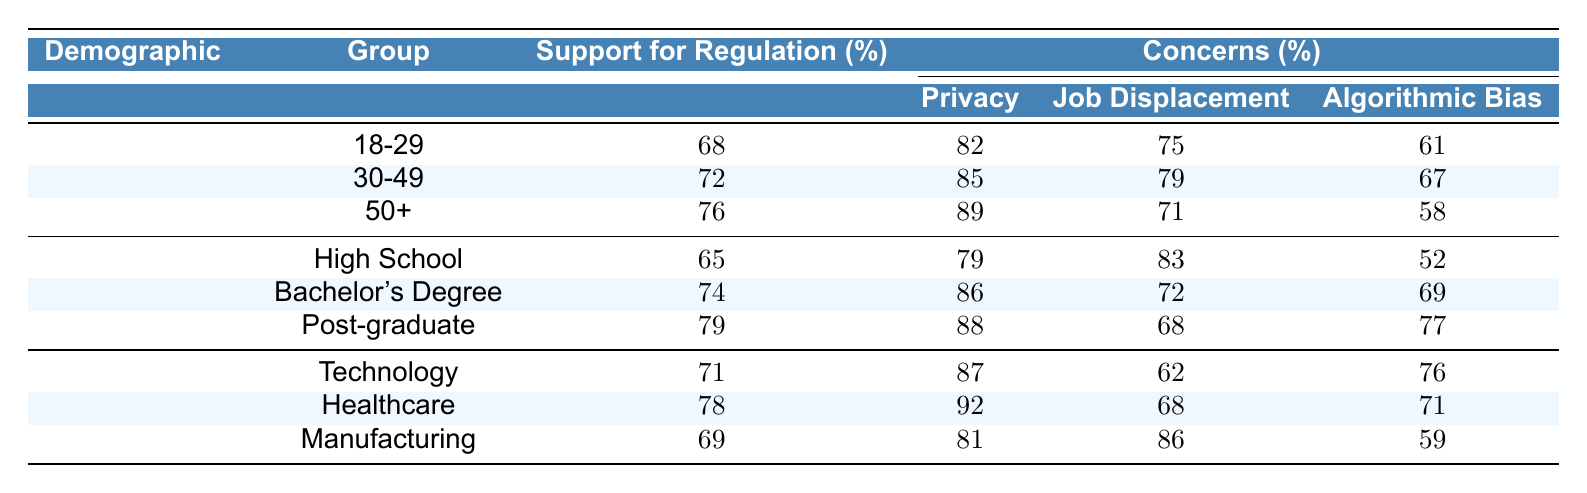What is the support for AI regulation among the 30-49 age group? The table lists the support for regulation under the Age Group demographic; for the 30-49 age group, the support for regulation is given as 72%.
Answer: 72 Which demographic group shows the highest concern for privacy? By looking at the concerns under "Privacy" across all demographic groups, the highest percentage is 89% for the 50+ age group.
Answer: 89 How does concern for job displacement compare between the 18-29 and 50+ age groups? The concern for job displacement is 75% for the 18-29 age group and 71% for the 50+ age group. The difference is 75% - 71% = 4%, meaning the 18-29 group has a higher concern.
Answer: 4% Overall, which education level has the most support for AI regulation? The table shows that the Post-graduate group has the highest support for regulation at 79%. The Bachelor's Degree group follows with 74%, and the High School group has 65%. So, Post-graduate level has the most support.
Answer: Post-graduate Is the concern for job displacement higher among high school graduates compared to post-graduates? The table indicates that the concern for job displacement is 83% for high school graduates and 68% for post-graduates. Therefore, the concern is higher among high school graduates.
Answer: Yes What is the average percentage of support for regulation across all age groups? To find the average, sum the support values: 68 + 72 + 76 = 216. Then divide by the number of groups (3): 216 / 3 = 72%.
Answer: 72 Which industry has the lowest concern for job displacement? The data shows that the Manufacturing industry has the highest concern for job displacement (86%), followed by Healthcare (68%) and Technology (62%). Therefore, Technology has the lowest concern.
Answer: Technology What is the percentage of concern for algorithmic bias in the Bachelor's Degree group? The table specifies that the concern for algorithmic bias in the Bachelor’s Degree group is 69%.
Answer: 69 Which age group shows the least concern for algorithmic bias, and what is the percentage? The 50+ age group shows the least concern for algorithmic bias at 58%, which is the lowest percentage in the Age Group category.
Answer: 58 Is there a difference between the support for regulation in the Technology and Healthcare industries? The support for regulation is 71% in Technology and 78% in Healthcare. The difference is 78% - 71% = 7%, with Healthcare showing higher support.
Answer: 7% 